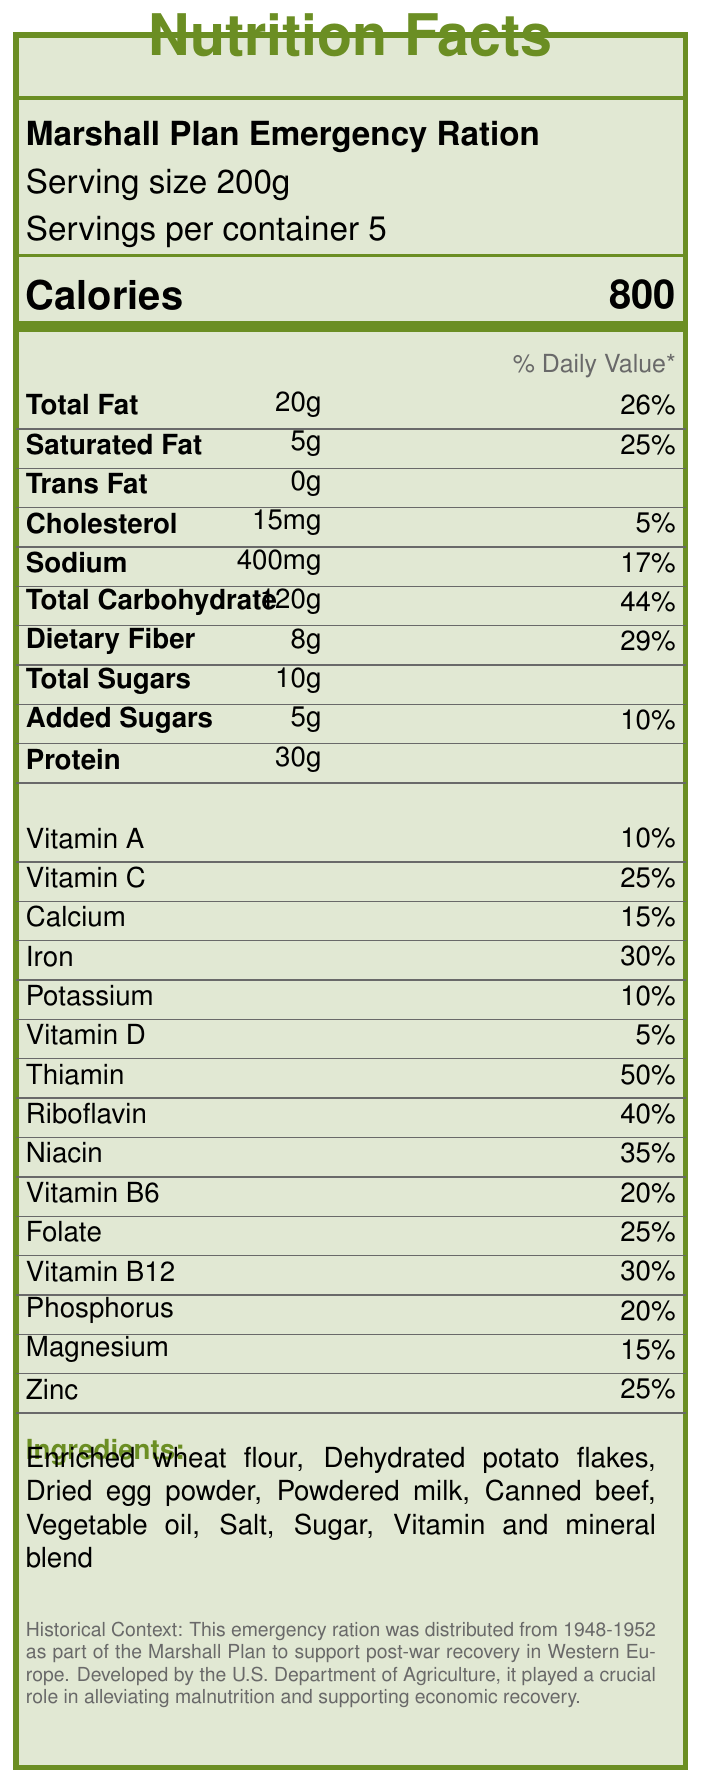What is the serving size of the Marshall Plan Emergency Ration? The document clearly states that the serving size of the Marshall Plan Emergency Ration is 200 grams.
Answer: 200g How many servings are there per container? The document specifies that there are 5 servings per container.
Answer: 5 How many calories are in one serving? The document lists 800 calories per serving under the calorie information section.
Answer: 800 What is the amount of total fat in one serving? Under the nutrient information, the total fat per serving is listed as 20 grams.
Answer: 20g What percentage of the daily value does iron cover? The vitamin information section indicates that one serving provides 30% of the daily value for iron.
Answer: 30% Which vitamin has the highest daily value percentage in this ration? A. Vitamin A B. Thiamin C. Niacin Thiamin has a daily value of 50%, which is the highest among the vitamins listed.
Answer: B What ingredient is not found in the Marshall Plan Emergency Ration? A. Enriched wheat flour B. Dehydrated potato flakes C. Fresh vegetables D. Dried egg powder Fresh vegetables are not listed among the ingredients.
Answer: C Was this ration developed by the U.S. Department of Agriculture? According to the historical note, the ration was indeed developed by the U.S. Department of Agriculture.
Answer: Yes Summarize the main purpose and content of the Marshall Plan Ration document. The explanation summarizes the key parts of the document, including the nutritional information provided, such as serving size, calorie count, and nutrient percentages, as well as the historical background and context of the ration's use.
Answer: The document outlines the nutritional profile and historical context of the Marshall Plan Emergency Ration, which was distributed from 1948-1952. It includes details on serving size, calories, and various nutrient contents. The historical context highlights its role in alleviating malnutrition and supporting economic recovery in post-war Western Europe. What was the primary goal of the Marshall Plan Emergency Ration? The historical context section mentions that the emergency ration was part of a larger effort to aid recovery and alleviate malnutrition after World War II.
Answer: To alleviate malnutrition and support economic recovery in post-war Western Europe. How much protein is in one serving of the ration? The nutrient information lists protein content as 30 grams per serving.
Answer: 30g Does the nutrition label specify any trans fats? The document shows '0g' for trans fats under the nutrient information section.
Answer: No What was the daily calorie distribution for individuals receiving these rations? The historical context notes that the average daily distribution was 2,000 calories per person.
Answer: 2,000 calories per person Which food preservation technique did the Marshall Plan introduce to Europe as per the long-term impact? A. Freezing B. Canning C. Fermentation The long-term impact states that the plan introduced American food preservation techniques, specifically increasing consumption of canned foods.
Answer: B Can you determine the approximate distribution period of these rations based on the document? The historical context clearly states that the distribution period for the rations was from 1948 to 1952.
Answer: Yes, 1948-1952 How much dietary fiber is in a single serving? The nutrient information indicates that dietary fiber content is 8 grams per serving.
Answer: 8g Is there any information about the exact geographical distribution of these rations within Western Europe? The document only mentions Western Europe generally; it does not provide exact geographical locations for the distribution.
Answer: Not enough information 